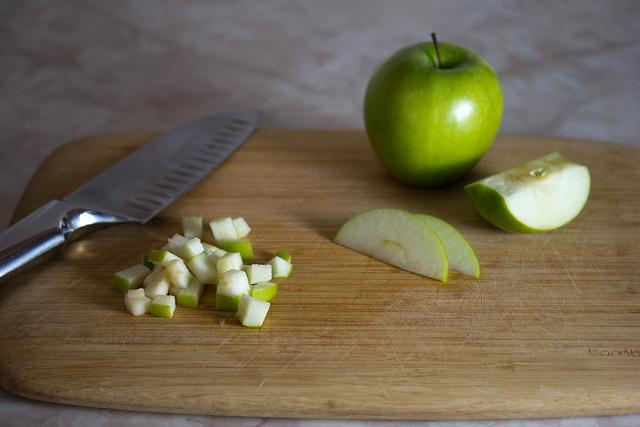How many apples have been cut up?
Short answer required. 1. Was the apple sliced or chopped?
Write a very short answer. Both. What type of blade is on the knife?
Give a very brief answer. Serrated. What is the apple sitting on?
Write a very short answer. Cutting board. 